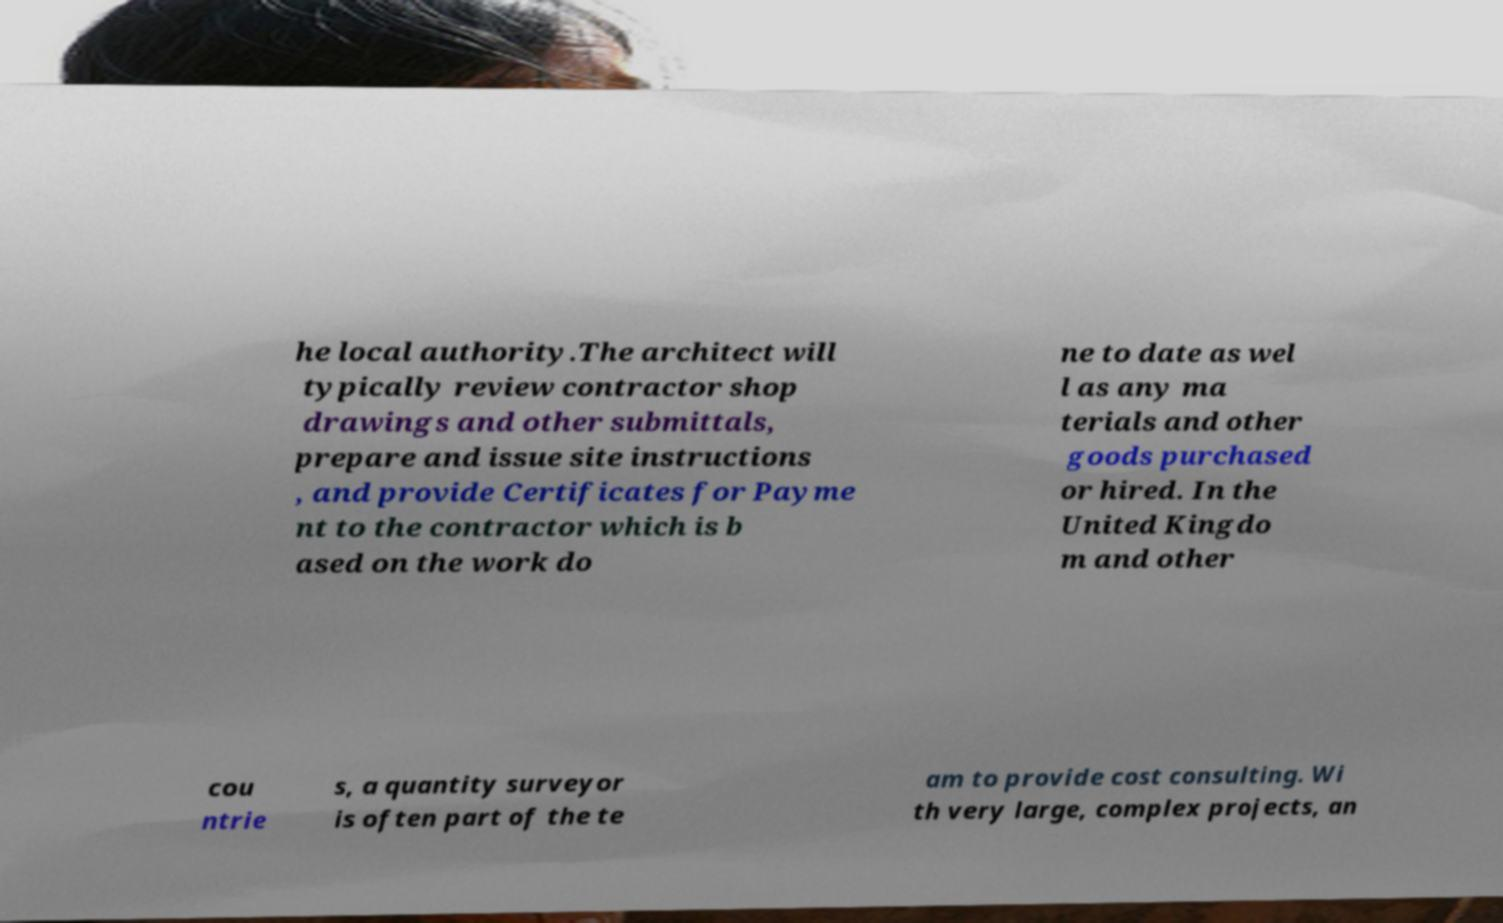What messages or text are displayed in this image? I need them in a readable, typed format. he local authority.The architect will typically review contractor shop drawings and other submittals, prepare and issue site instructions , and provide Certificates for Payme nt to the contractor which is b ased on the work do ne to date as wel l as any ma terials and other goods purchased or hired. In the United Kingdo m and other cou ntrie s, a quantity surveyor is often part of the te am to provide cost consulting. Wi th very large, complex projects, an 